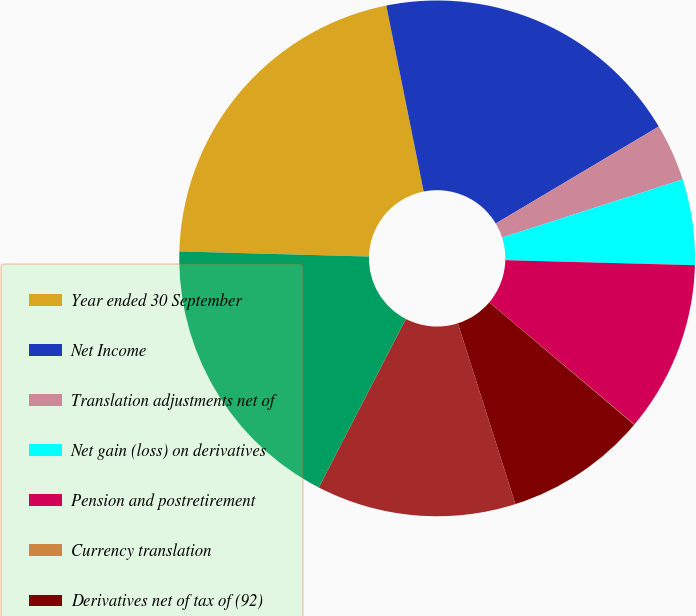<chart> <loc_0><loc_0><loc_500><loc_500><pie_chart><fcel>Year ended 30 September<fcel>Net Income<fcel>Translation adjustments net of<fcel>Net gain (loss) on derivatives<fcel>Pension and postretirement<fcel>Currency translation<fcel>Derivatives net of tax of (92)<fcel>Total Other Comprehensive<fcel>Comprehensive Income<nl><fcel>21.41%<fcel>19.62%<fcel>3.59%<fcel>5.37%<fcel>10.72%<fcel>0.02%<fcel>8.93%<fcel>12.5%<fcel>17.84%<nl></chart> 